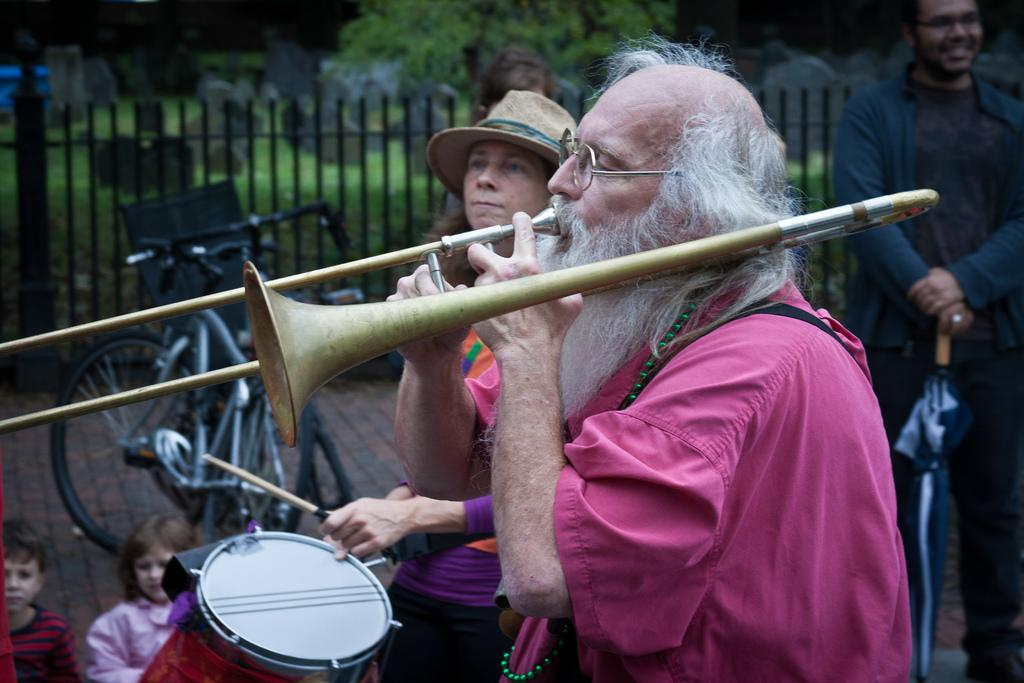How many persons are playing musical instruments in the image? There are two persons playing musical instruments in the image. What can be seen in the background of the image? In the background, there is a fence, a bicycle, a walkway, plants, a cemetery, a tree, and people. Can you describe the fence in the background? The fence in the background is a simple structure, likely made of wood or metal. What color is the tooth that is being played by one of the musicians in the image? There is no tooth present in the image; the musicians are playing musical instruments. What is the position of the orange in the image? There is no orange present in the image. 